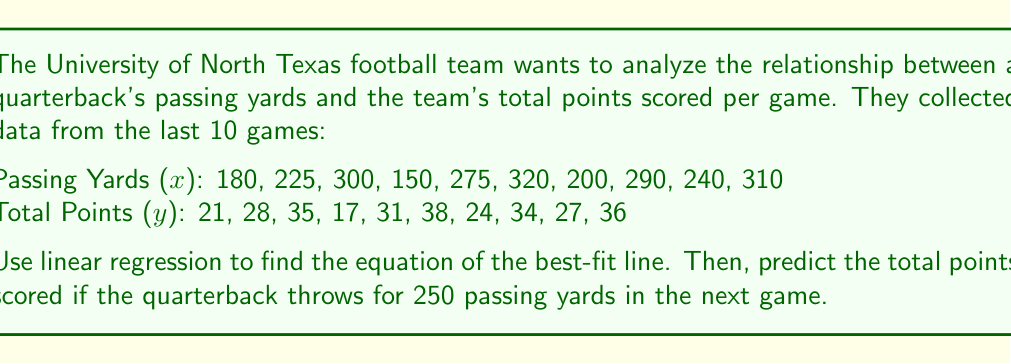Teach me how to tackle this problem. Let's approach this step-by-step using linear regression:

1. We need to calculate the following values:
   $n = 10$ (number of data points)
   $\sum x$, $\sum y$, $\sum xy$, $\sum x^2$

2. Calculate the sums:
   $\sum x = 2490$
   $\sum y = 291$
   $\sum xy = 74,470$
   $\sum x^2 = 650,700$

3. Use the linear regression formulas to find the slope (m) and y-intercept (b):

   $$m = \frac{n\sum xy - \sum x \sum y}{n\sum x^2 - (\sum x)^2}$$
   
   $$b = \frac{\sum y - m\sum x}{n}$$

4. Plug in the values:

   $$m = \frac{10(74,470) - (2490)(291)}{10(650,700) - (2490)^2} = 0.0936$$

   $$b = \frac{291 - 0.0936(2490)}{10} = 5.7304$$

5. The equation of the best-fit line is:
   $$y = 0.0936x + 5.7304$$

6. To predict the total points for 250 passing yards, plug x = 250 into the equation:
   $$y = 0.0936(250) + 5.7304 = 29.1304$$
Answer: $y = 0.0936x + 5.7304$; 29.13 points 